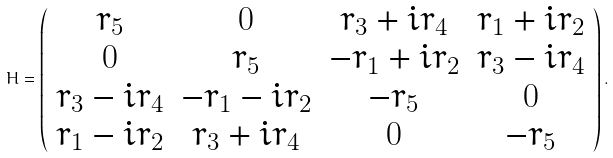<formula> <loc_0><loc_0><loc_500><loc_500>H = \left ( \begin{array} { c c c c } { { r _ { 5 } } } & { 0 } & { { r _ { 3 } + i r _ { 4 } } } & { { r _ { 1 } + i r _ { 2 } } } \\ { 0 } & { { r _ { 5 } } } & { { - r _ { 1 } + i r _ { 2 } } } & { { r _ { 3 } - i r _ { 4 } } } \\ { { r _ { 3 } - i r _ { 4 } } } & { { - r _ { 1 } - i r _ { 2 } } } & { { - r _ { 5 } } } & { 0 } \\ { { r _ { 1 } - i r _ { 2 } } } & { { r _ { 3 } + i r _ { 4 } } } & { 0 } & { { - r _ { 5 } } } \end{array} \right ) .</formula> 